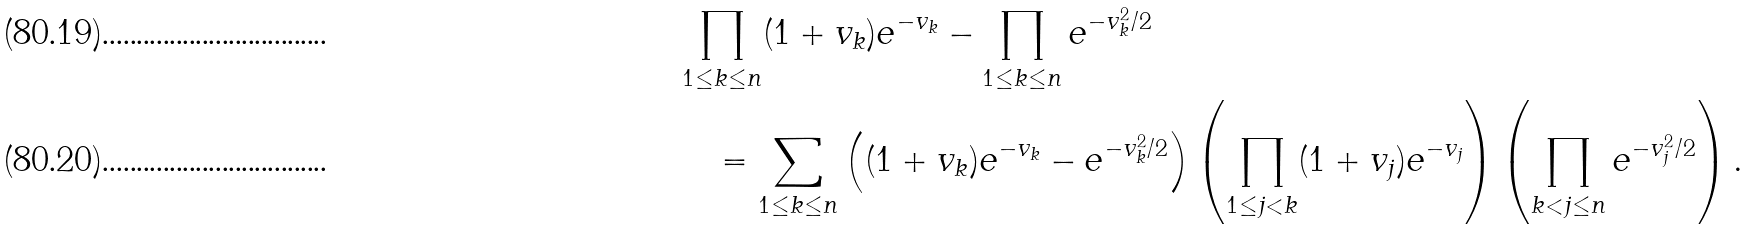Convert formula to latex. <formula><loc_0><loc_0><loc_500><loc_500>& \prod _ { 1 \leq k \leq n } ( 1 + v _ { k } ) e ^ { - v _ { k } } - \prod _ { 1 \leq k \leq n } e ^ { - v _ { k } ^ { 2 } / 2 } \\ & \quad = \sum _ { 1 \leq k \leq n } \left ( ( 1 + v _ { k } ) e ^ { - v _ { k } } - e ^ { - v _ { k } ^ { 2 } / 2 } \right ) \left ( \prod _ { 1 \leq j < k } ( 1 + v _ { j } ) e ^ { - v _ { j } } \right ) \left ( \prod _ { k < j \leq n } e ^ { - v _ { j } ^ { 2 } / 2 } \right ) .</formula> 